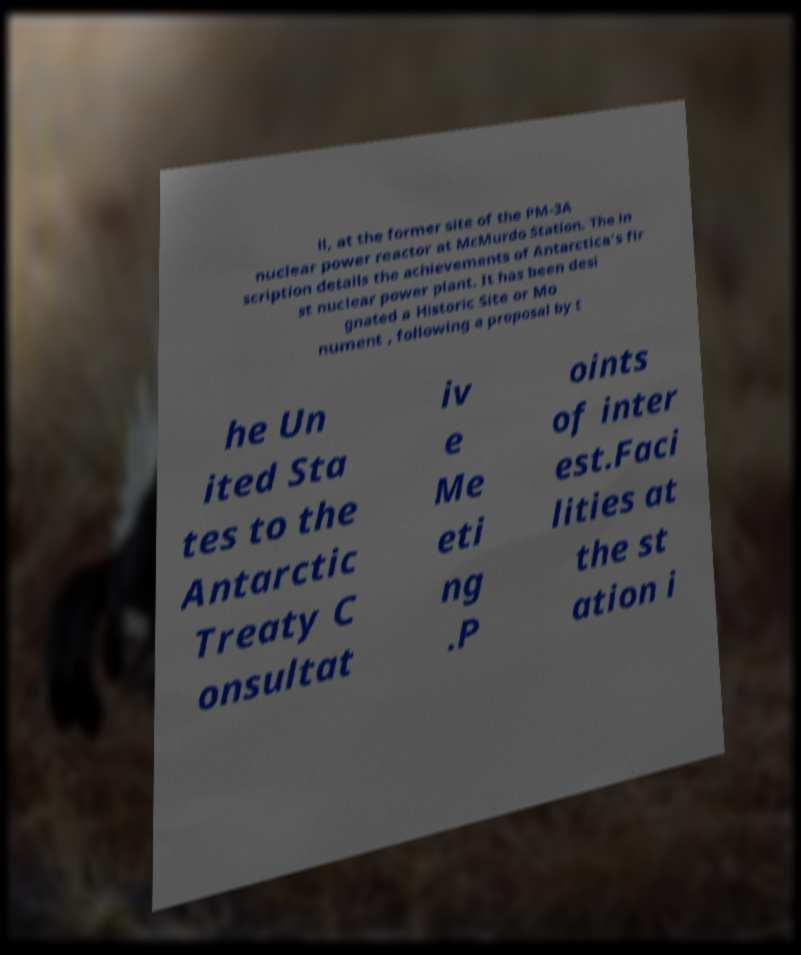Could you assist in decoding the text presented in this image and type it out clearly? ll, at the former site of the PM-3A nuclear power reactor at McMurdo Station. The in scription details the achievements of Antarctica's fir st nuclear power plant. It has been desi gnated a Historic Site or Mo nument , following a proposal by t he Un ited Sta tes to the Antarctic Treaty C onsultat iv e Me eti ng .P oints of inter est.Faci lities at the st ation i 